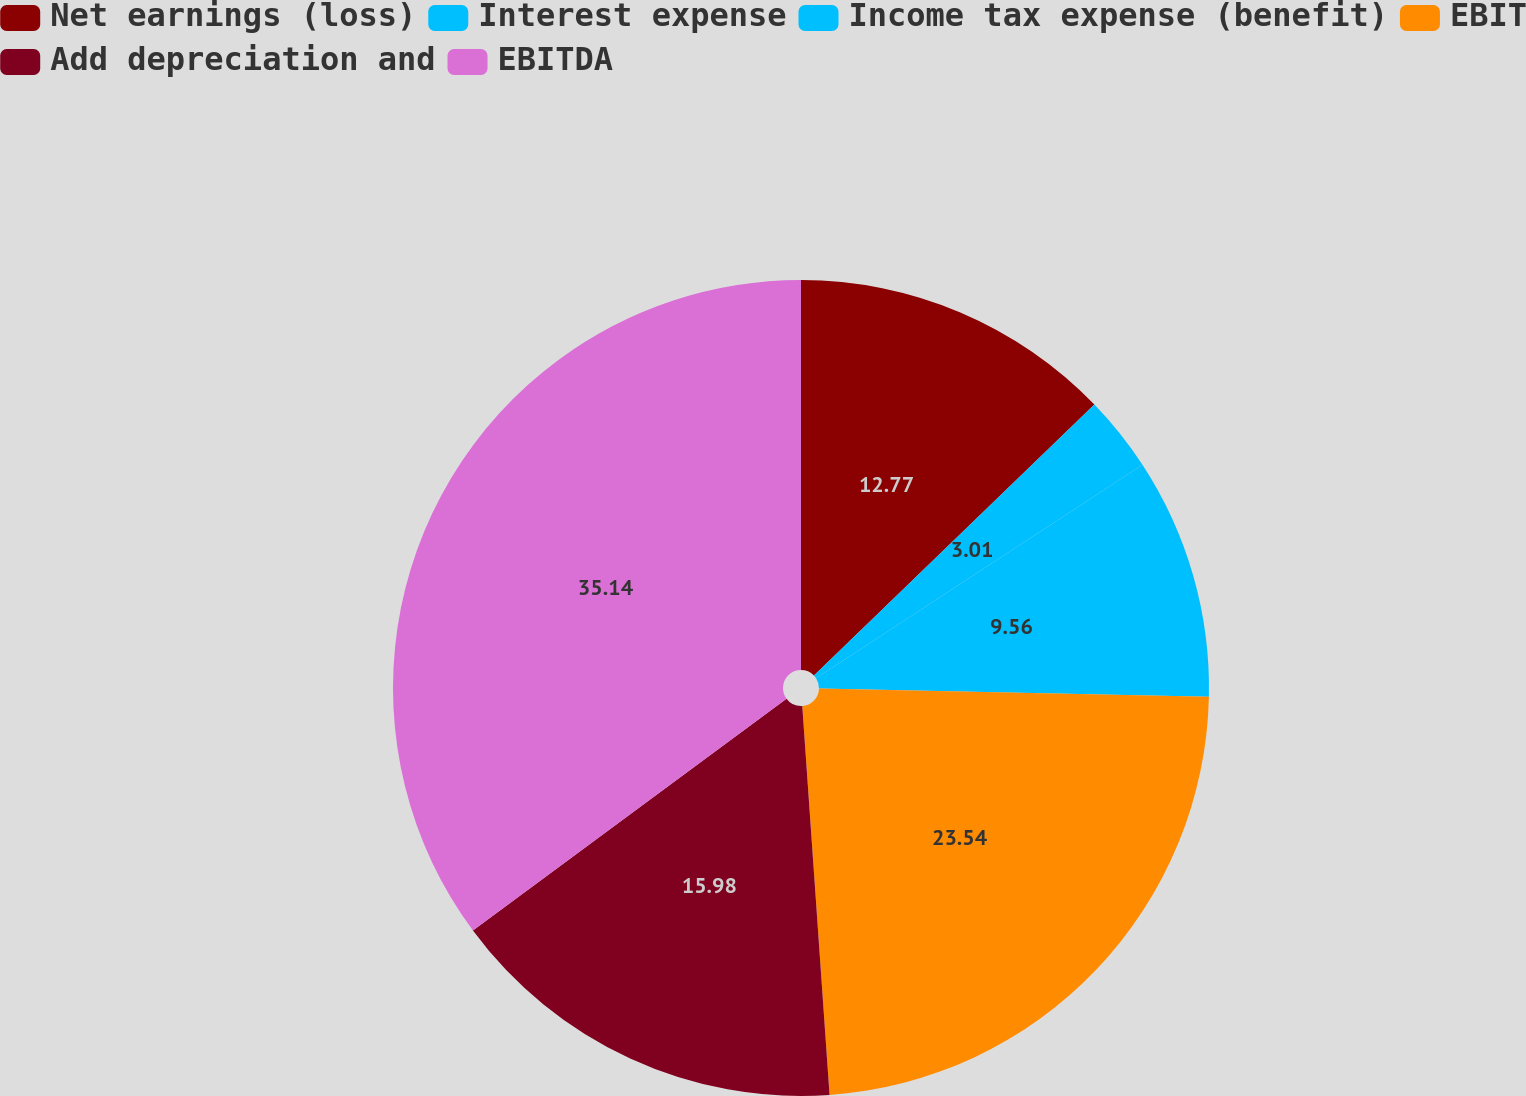Convert chart to OTSL. <chart><loc_0><loc_0><loc_500><loc_500><pie_chart><fcel>Net earnings (loss)<fcel>Interest expense<fcel>Income tax expense (benefit)<fcel>EBIT<fcel>Add depreciation and<fcel>EBITDA<nl><fcel>12.77%<fcel>3.01%<fcel>9.56%<fcel>23.54%<fcel>15.98%<fcel>35.13%<nl></chart> 